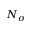Convert formula to latex. <formula><loc_0><loc_0><loc_500><loc_500>N _ { \sigma }</formula> 